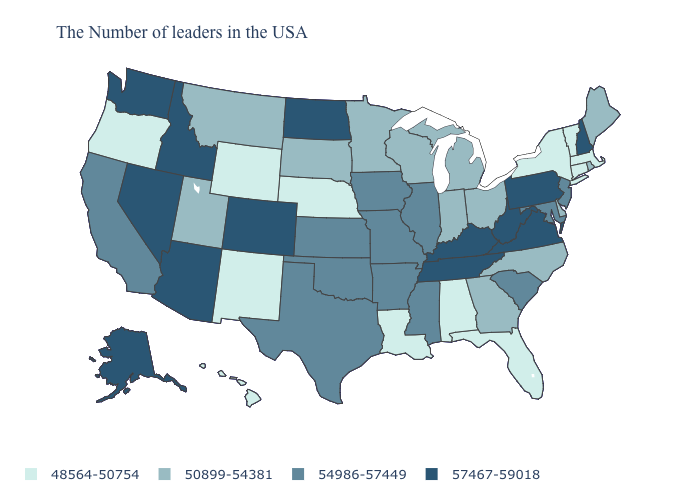Does the map have missing data?
Be succinct. No. Name the states that have a value in the range 50899-54381?
Be succinct. Maine, Rhode Island, Delaware, North Carolina, Ohio, Georgia, Michigan, Indiana, Wisconsin, Minnesota, South Dakota, Utah, Montana. Which states hav the highest value in the South?
Short answer required. Virginia, West Virginia, Kentucky, Tennessee. How many symbols are there in the legend?
Short answer required. 4. Name the states that have a value in the range 50899-54381?
Concise answer only. Maine, Rhode Island, Delaware, North Carolina, Ohio, Georgia, Michigan, Indiana, Wisconsin, Minnesota, South Dakota, Utah, Montana. Name the states that have a value in the range 54986-57449?
Be succinct. New Jersey, Maryland, South Carolina, Illinois, Mississippi, Missouri, Arkansas, Iowa, Kansas, Oklahoma, Texas, California. Does the map have missing data?
Be succinct. No. What is the lowest value in the USA?
Keep it brief. 48564-50754. Which states have the lowest value in the USA?
Short answer required. Massachusetts, Vermont, Connecticut, New York, Florida, Alabama, Louisiana, Nebraska, Wyoming, New Mexico, Oregon, Hawaii. Among the states that border Oregon , which have the highest value?
Be succinct. Idaho, Nevada, Washington. Does North Dakota have the same value as Nevada?
Concise answer only. Yes. Name the states that have a value in the range 54986-57449?
Give a very brief answer. New Jersey, Maryland, South Carolina, Illinois, Mississippi, Missouri, Arkansas, Iowa, Kansas, Oklahoma, Texas, California. Name the states that have a value in the range 54986-57449?
Be succinct. New Jersey, Maryland, South Carolina, Illinois, Mississippi, Missouri, Arkansas, Iowa, Kansas, Oklahoma, Texas, California. Does South Dakota have the lowest value in the MidWest?
Keep it brief. No. 